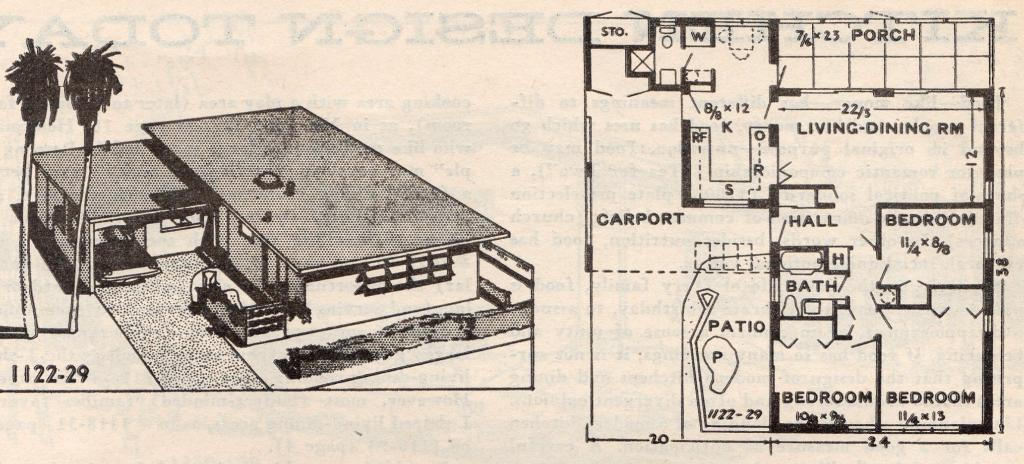Please provide a concise description of this image. This is a picture of a paper , where there are photos of a house, there are trees, numbers , words , and measurements of the interior part of the house on the paper. 